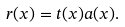Convert formula to latex. <formula><loc_0><loc_0><loc_500><loc_500>r ( x ) = t ( x ) a ( x ) .</formula> 